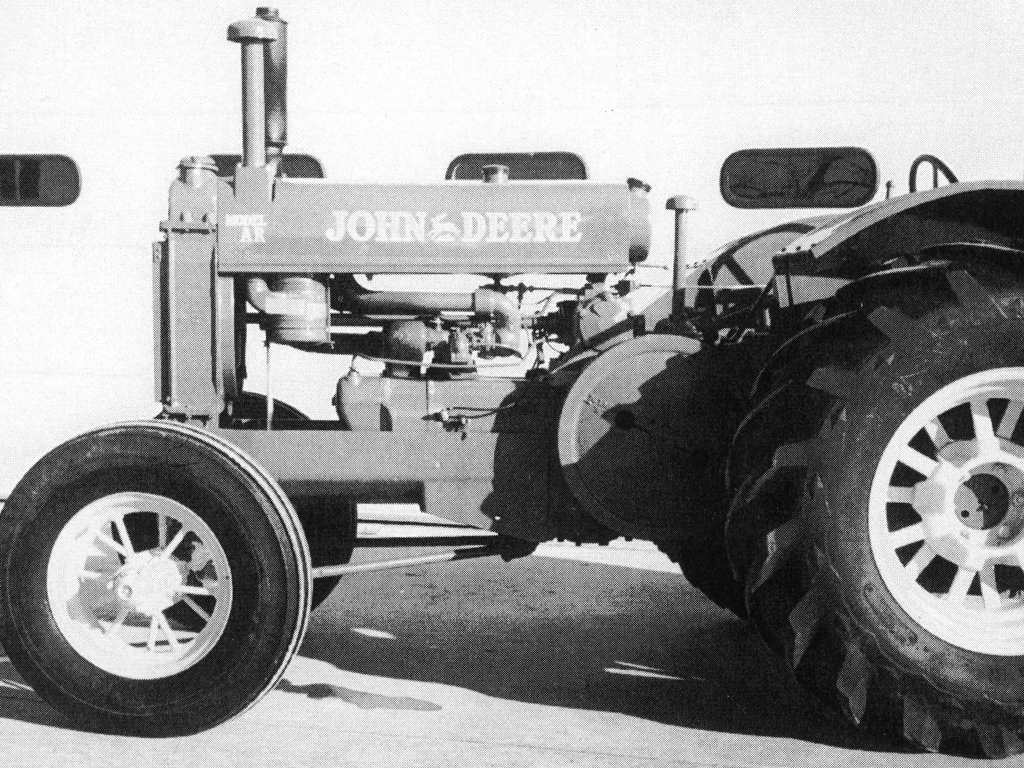What is the historical significance of this type of tractor? Tractors of this type played a crucial role in agricultural mechanization—a transformative period in farming. They greatly increased efficiency, allowing for larger farms and more effective land use. This particular model is likely to be an example of the industrial design and technological innovation characteristic of its production era, which contributed to the modernization of farming practices. 